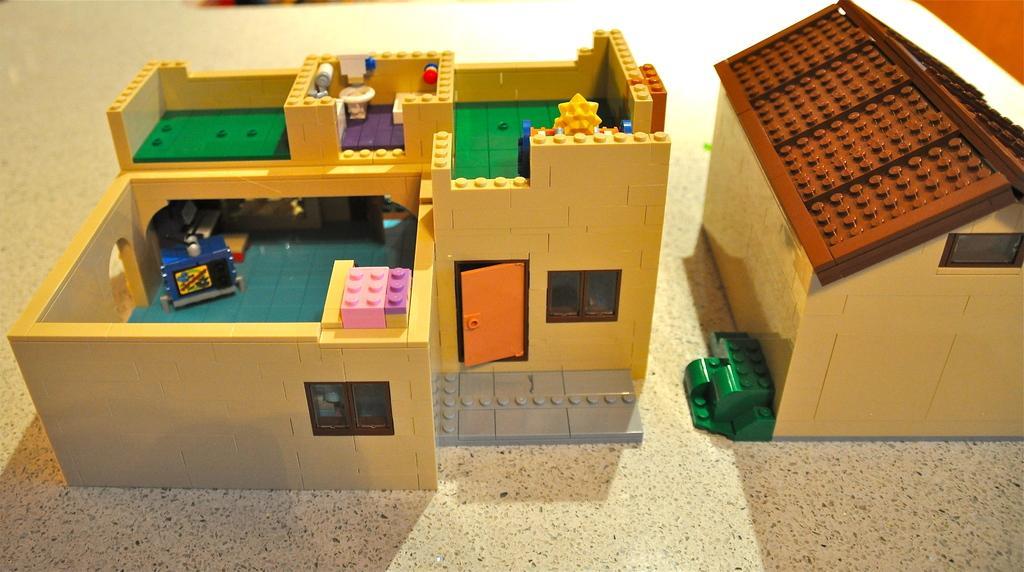How would you summarize this image in a sentence or two? In this image I can see two houses with Lego. There are in different colors and I can see few objects inside. They are on the surface. 